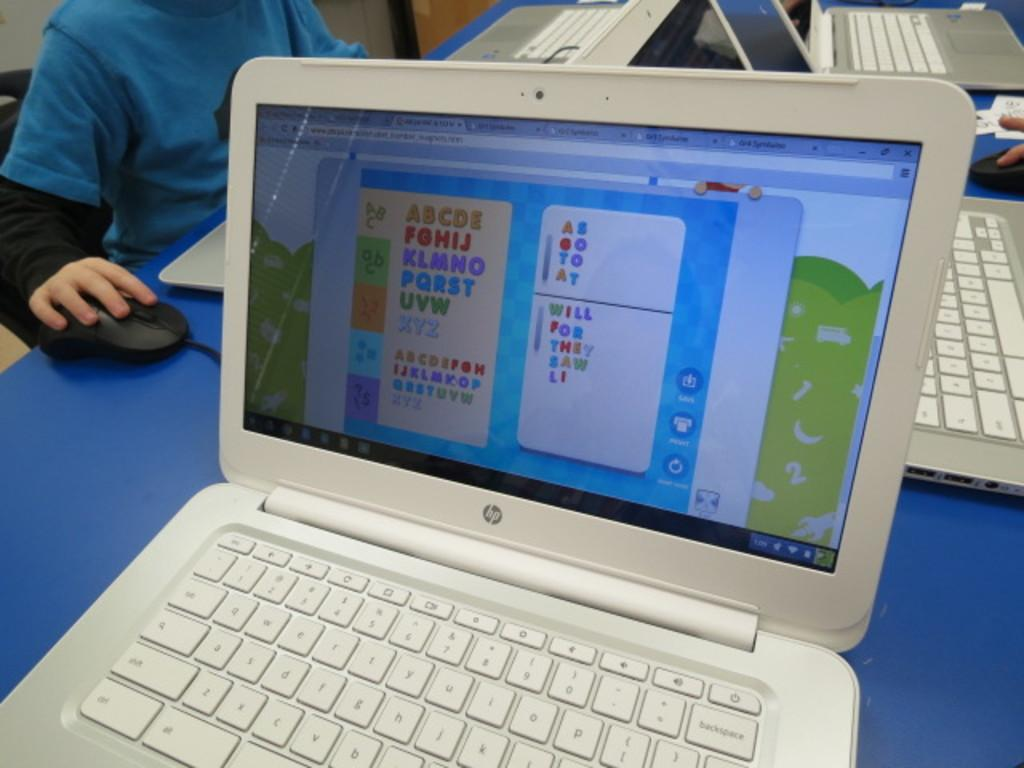<image>
Provide a brief description of the given image. A white opened laptop with the alphabet on the screen. 